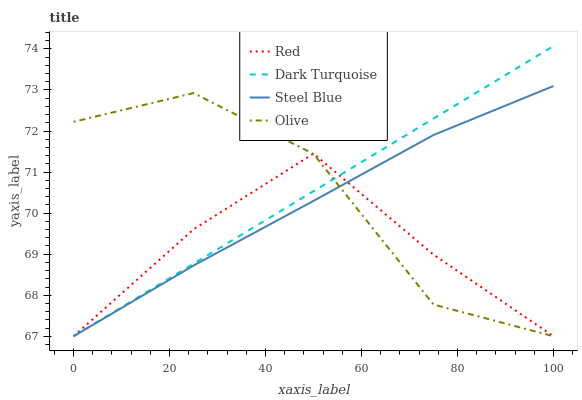Does Red have the minimum area under the curve?
Answer yes or no. Yes. Does Dark Turquoise have the maximum area under the curve?
Answer yes or no. Yes. Does Steel Blue have the minimum area under the curve?
Answer yes or no. No. Does Steel Blue have the maximum area under the curve?
Answer yes or no. No. Is Dark Turquoise the smoothest?
Answer yes or no. Yes. Is Olive the roughest?
Answer yes or no. Yes. Is Steel Blue the smoothest?
Answer yes or no. No. Is Steel Blue the roughest?
Answer yes or no. No. Does Dark Turquoise have the highest value?
Answer yes or no. Yes. Does Steel Blue have the highest value?
Answer yes or no. No. Does Olive intersect Red?
Answer yes or no. Yes. Is Olive less than Red?
Answer yes or no. No. Is Olive greater than Red?
Answer yes or no. No. 